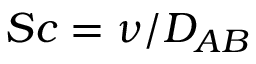Convert formula to latex. <formula><loc_0><loc_0><loc_500><loc_500>S c = \nu / D _ { A B }</formula> 